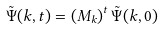Convert formula to latex. <formula><loc_0><loc_0><loc_500><loc_500>\tilde { \Psi } ( k , t ) = \left ( M _ { k } \right ) ^ { t } \tilde { \Psi } ( k , 0 )</formula> 